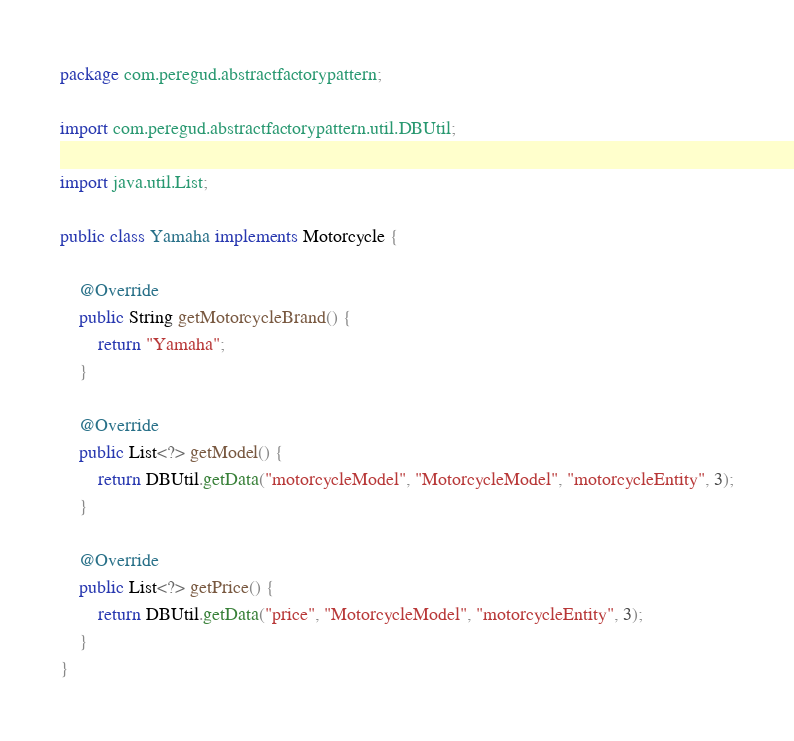<code> <loc_0><loc_0><loc_500><loc_500><_Java_>package com.peregud.abstractfactorypattern;

import com.peregud.abstractfactorypattern.util.DBUtil;

import java.util.List;

public class Yamaha implements Motorcycle {

    @Override
    public String getMotorcycleBrand() {
        return "Yamaha";
    }

    @Override
    public List<?> getModel() {
        return DBUtil.getData("motorcycleModel", "MotorcycleModel", "motorcycleEntity", 3);
    }

    @Override
    public List<?> getPrice() {
        return DBUtil.getData("price", "MotorcycleModel", "motorcycleEntity", 3);
    }
}
</code> 